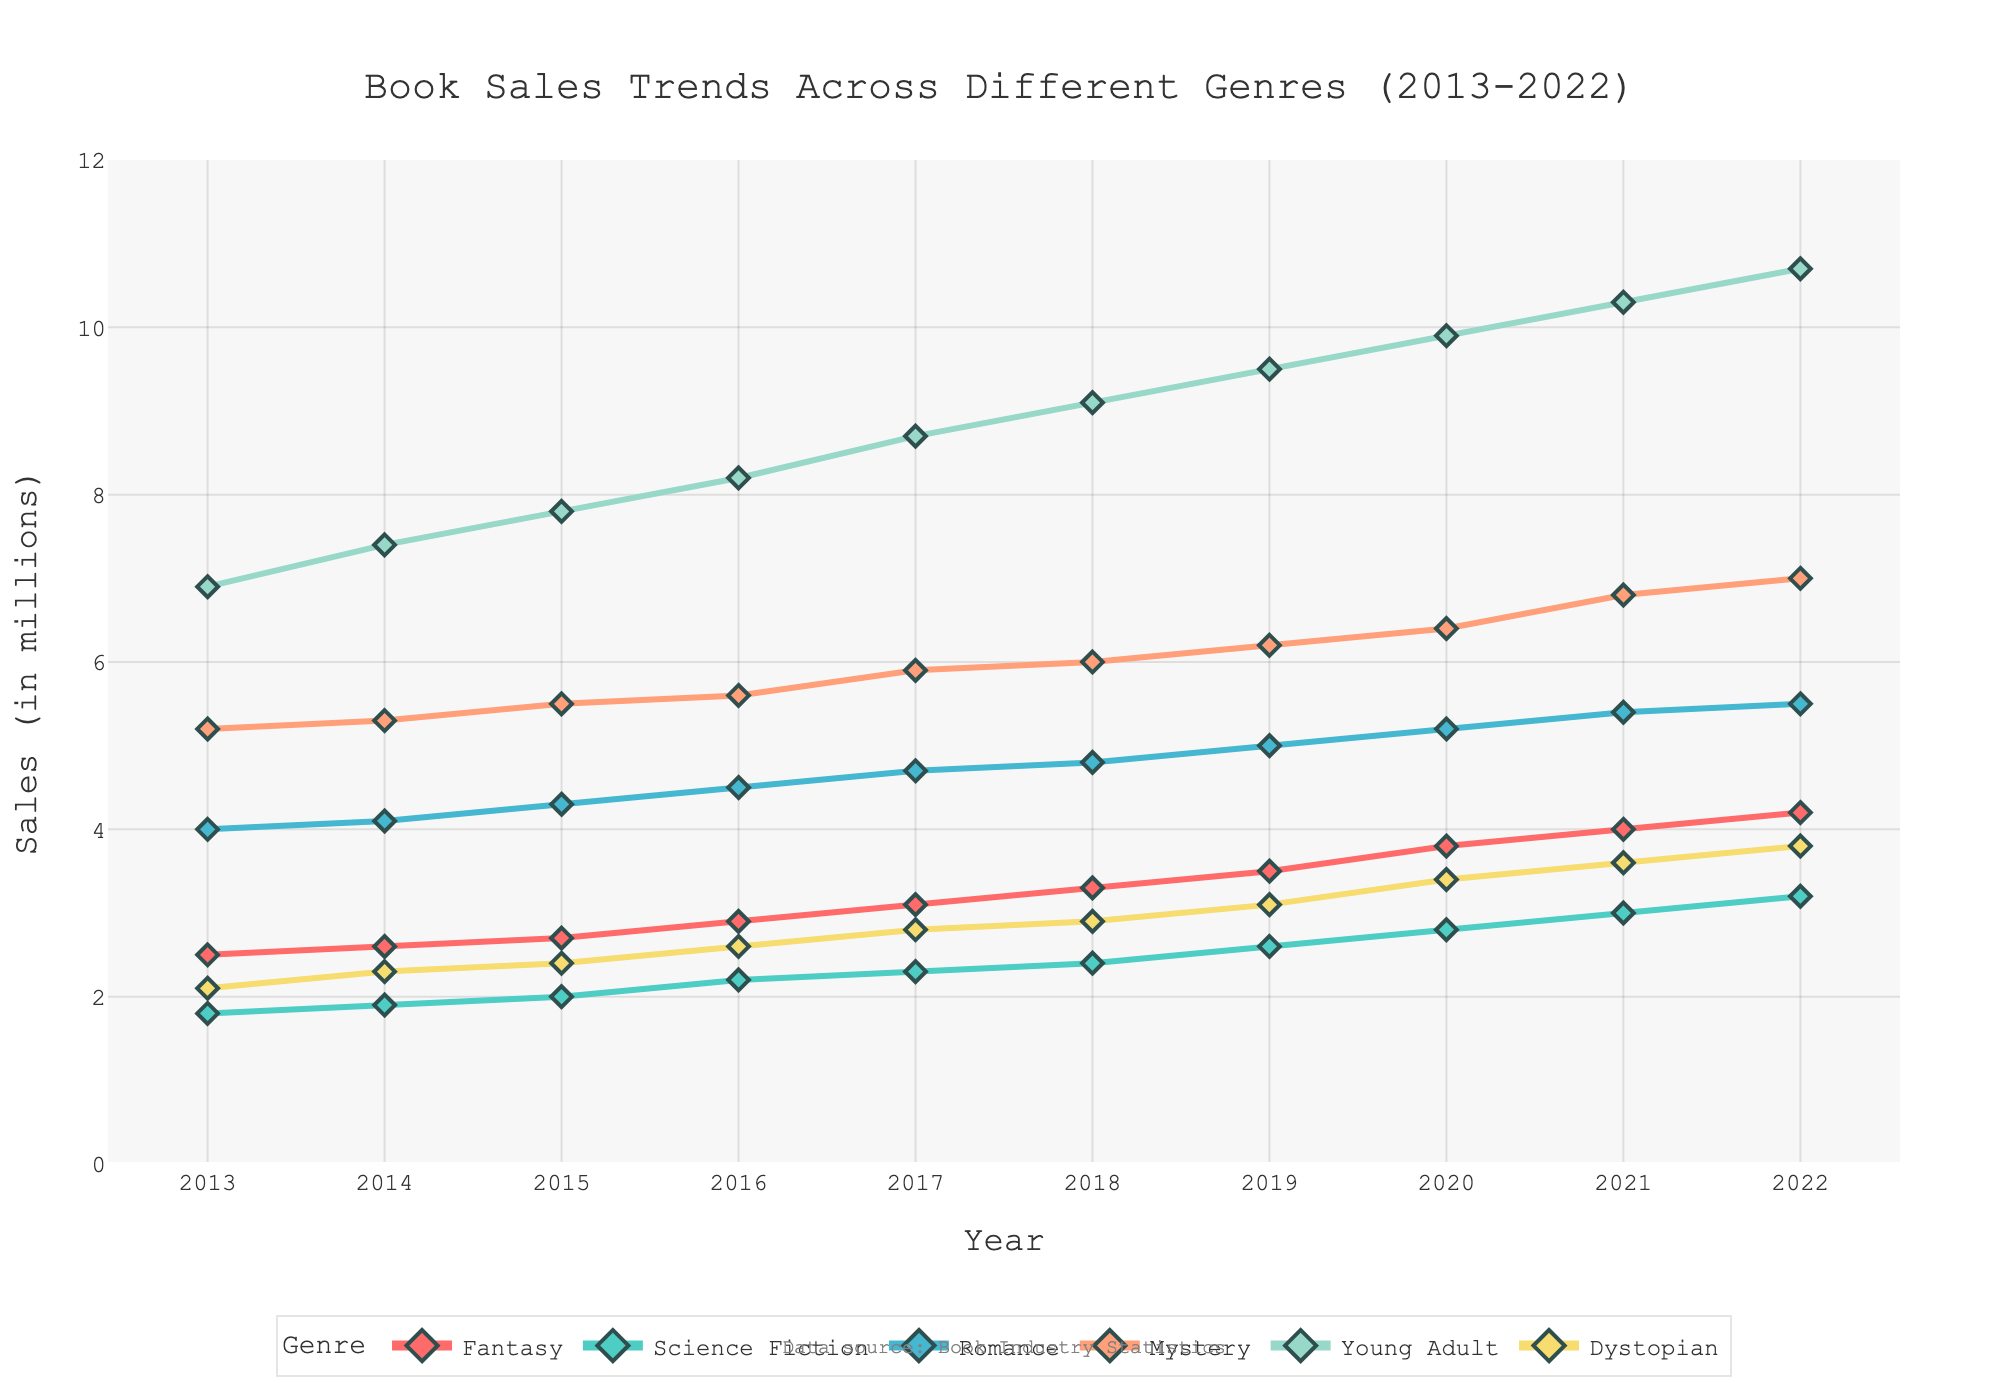What is the title of the figure? The title is usually displayed at the top of the figure. Here, it reads "Book Sales Trends Across Different Genres (2013-2022)".
Answer: Book Sales Trends Across Different Genres (2013-2022) What are the units of measurement on the y-axis? The y-axis title indicates the units of measurement. It reads "Sales (in millions)".
Answer: Sales (in millions) Which genre had the highest sales in 2022? By tracing the lines to the rightmost points on the plot, you can see that the "Young Adult" genre had the highest sales in 2022.
Answer: Young Adult Which genre had a consistent increase in sales every year? By observing the trend lines for each genre, it is evident that "Young Adult" had a consistent increase in sales from 2013 to 2022.
Answer: Young Adult What is the difference in sales between "Fantasy" and "Science Fiction" genres in 2020? First, find the sales of "Fantasy" in 2020, which is 3.8 million, and of "Science Fiction", which is 2.8 million. The difference is 3.8 - 2.8 = 1.0 million.
Answer: 1.0 million Which genre showed the smallest increase in sales from 2013 to 2022? To identify this, calculate the difference in sales values for each genre between 2013 and 2022, and the smallest increment indicates the genre. "Science Fiction" increased from 1.8 to 3.2, a difference of 1.4 million, which is the smallest increase among the genres.
Answer: Science Fiction In what year did the "Mystery" genre see a notable sales increase? Observing the trend line for "Mystery", there is a noticeable increase in sales between 2020 and 2021, where it jumps from around 6.4 million to approximately 6.8 million.
Answer: 2021 Which two genres had the closest sales figures in 2018? Comparing the data points for 2018, "Science Fiction" had sales of 2.4 million and "Dystopian" had sales of 2.9 million. These values are closest in proximity.
Answer: Science Fiction and Dystopian What is the average sales figure for the "Romance" genre over the decade? Sum the sales figures for "Romance" from 2013 to 2022 and then divide by 10. The sum is 4.0 + 4.1 + 4.3 + 4.5 + 4.7 + 4.8 + 5.0 + 5.2 + 5.4 + 5.5 = 47.5, so the average is 47.5 / 10 = 4.75 million.
Answer: 4.75 million 